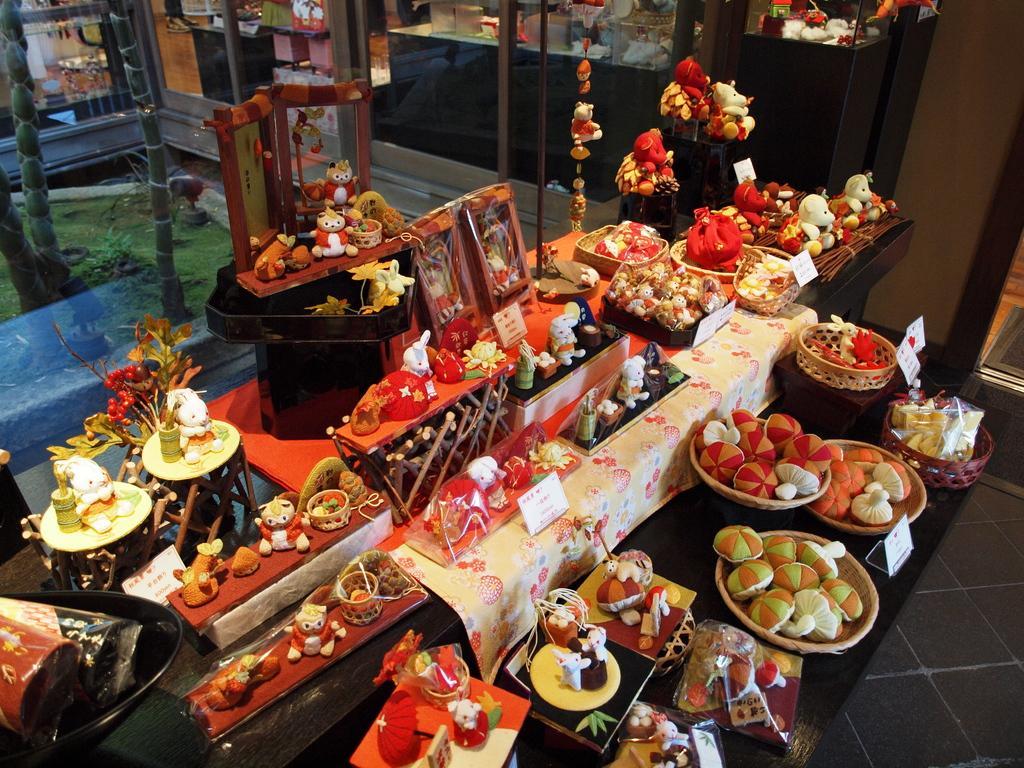Could you give a brief overview of what you see in this image? On the table we can see the plates, bowls, sweets, frames, toys, cotton boxes, cloth, paper, flower and other objects. In the background we can see the table and wall. On the left we can see tree, plant and grass. 